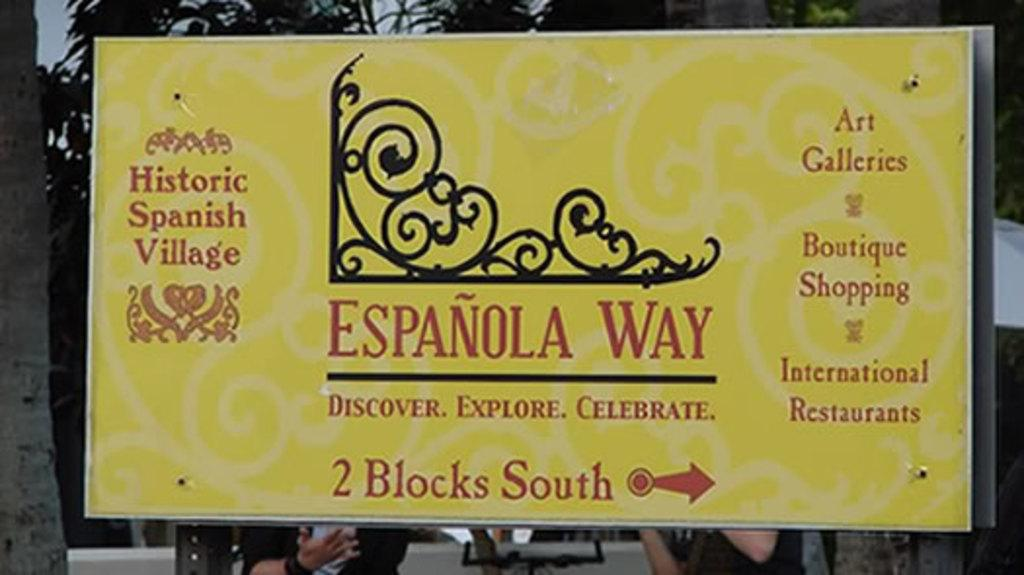What is the color of the hoarding in the image? The hoarding in the image is yellow. What can be found on the hoarding besides its color? The hoarding contains texts. What type of spoon is being used by the achiever in the image? There is no achiever or spoon present in the image; it only features a yellow hoarding with texts. 